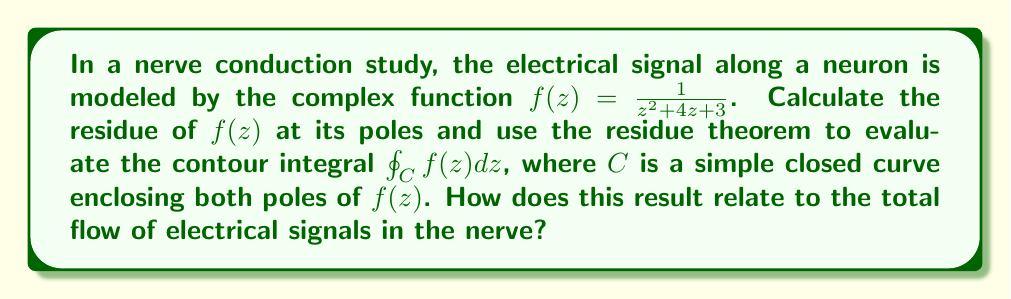Give your solution to this math problem. Let's approach this step-by-step:

1) First, we need to find the poles of $f(z)$. The denominator of $f(z)$ is $z^2 + 4z + 3$, which we can factor:

   $z^2 + 4z + 3 = (z+1)(z+3)$

   So, the poles are at $z = -1$ and $z = -3$.

2) Now, let's calculate the residues at these poles. For a simple pole at $z = a$, the residue is given by:

   $\text{Res}(f, a) = \lim_{z \to a} (z-a)f(z)$

3) For $z = -1$:
   $$\text{Res}(f, -1) = \lim_{z \to -1} (z+1)\frac{1}{z^2 + 4z + 3} = \lim_{z \to -1} \frac{1}{z+3} = \frac{1}{2}$$

4) For $z = -3$:
   $$\text{Res}(f, -3) = \lim_{z \to -3} (z+3)\frac{1}{z^2 + 4z + 3} = \lim_{z \to -3} \frac{1}{z+1} = -\frac{1}{2}$$

5) The residue theorem states that for a meromorphic function $f(z)$ inside and on a simple closed contour $C$:

   $$\oint_C f(z) dz = 2\pi i \sum \text{Res}(f, a_k)$$

   where $a_k$ are the poles of $f(z)$ inside $C$.

6) Applying the residue theorem:

   $$\oint_C f(z) dz = 2\pi i (\frac{1}{2} - \frac{1}{2}) = 0$$

This result indicates that the net flow of electrical signals around the closed contour is zero. In the context of nerve conduction, this suggests that the total electrical charge is conserved in the system, with any outward flow balanced by an equal inward flow.
Answer: The contour integral $\oint_C f(z) dz = 0$, indicating that the net flow of electrical signals around the closed contour is zero, consistent with the conservation of electrical charge in nerve conduction. 